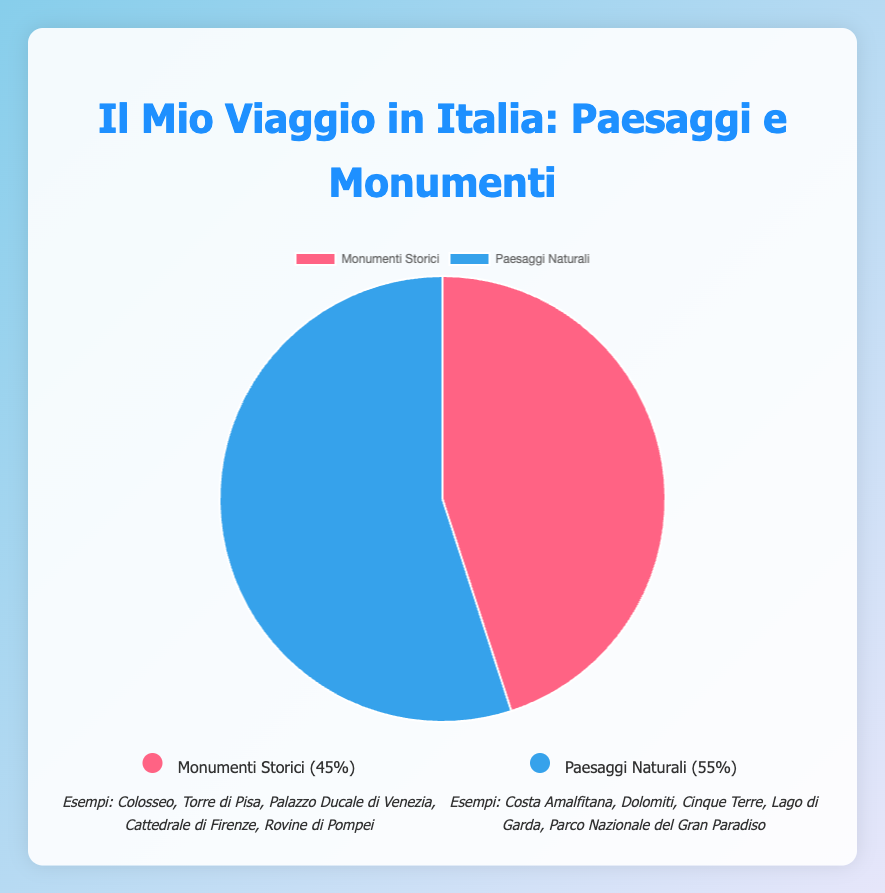What is the percentage of people who prefer Historical Landmarks? The figure indicates that the section for Historical Landmarks is colored red and labeled with a percentage. By referring to this section, we can see that it is 45%.
Answer: 45% What type of scenery is preferred more, and by how much? To determine this, compare the percentages given for both scenery types. Historical Landmarks have 45%, while Natural Landscapes, indicated in blue, have 55%. Calculate the difference: 55% - 45% = 10%.
Answer: Natural Landscapes, by 10% What are some examples of Natural Landscapes mentioned in the figure? The legend provides specific examples for each category. For Natural Landscapes, view the blue section's legend which lists "Amalfi Coast," "Dolomites," "Cinque Terre," "Lake Garda," "Gran Paradiso National Park."
Answer: Amalfi Coast, Dolomites, Cinque Terre, Lake Garda, Gran Paradiso National Park How much of the total percentage is accounted for by both sceneries combined? Verify that the total combined percentage for both sections adds up to 100%. Sum 45% (Historical Landmarks) and 55% (Natural Landscapes). 45% + 55% = 100%.
Answer: 100% If 200 people were surveyed, how many of them prefer Natural Landscapes? To calculate this, use the percentage for Natural Landscapes (55%) and apply it to the total number of people surveyed (200). 200 * 0.55 = 110 people.
Answer: 110 Which color represents Historical Landmarks on the plot? The legend shows that Historical Landmarks are associated with the red color section of the pie chart.
Answer: Red Is the difference between people who like Historical Landmarks and Natural Landscapes higher or lower than 15%? Determine the actual difference between both percentages: 55% (Natural Landscapes) - 45% (Historical Landmarks) = 10%. Since 10% is less than 15%, the difference is lower than 15%.
Answer: Lower Which segment occupies more area in the pie chart, and by how much? Compare the pie chart segments visually and by their given percentages: Natural Landscapes have 55%, while Historical Landmarks have 45%. So, Natural Landscapes occupy more area by 10%.
Answer: Natural Landscapes, by 10% 